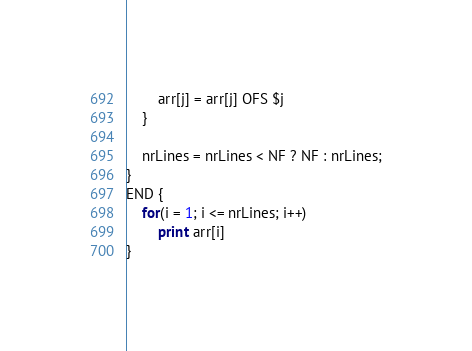<code> <loc_0><loc_0><loc_500><loc_500><_Awk_>		arr[j] = arr[j] OFS $j
	}
	
	nrLines = nrLines < NF ? NF : nrLines;
}
END {
	for(i = 1; i <= nrLines; i++)
		print arr[i]
}
</code> 